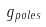Convert formula to latex. <formula><loc_0><loc_0><loc_500><loc_500>g _ { p o l e s }</formula> 